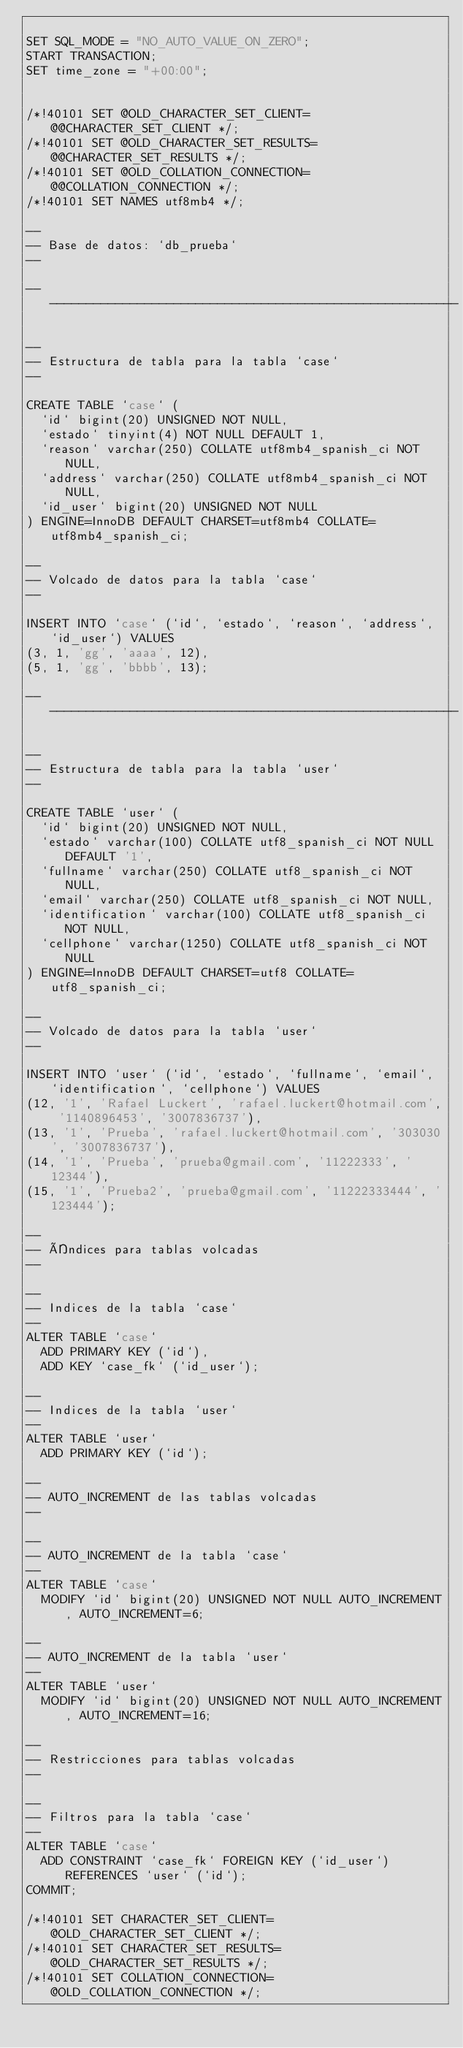Convert code to text. <code><loc_0><loc_0><loc_500><loc_500><_SQL_>
SET SQL_MODE = "NO_AUTO_VALUE_ON_ZERO";
START TRANSACTION;
SET time_zone = "+00:00";


/*!40101 SET @OLD_CHARACTER_SET_CLIENT=@@CHARACTER_SET_CLIENT */;
/*!40101 SET @OLD_CHARACTER_SET_RESULTS=@@CHARACTER_SET_RESULTS */;
/*!40101 SET @OLD_COLLATION_CONNECTION=@@COLLATION_CONNECTION */;
/*!40101 SET NAMES utf8mb4 */;

--
-- Base de datos: `db_prueba`
--

-- --------------------------------------------------------

--
-- Estructura de tabla para la tabla `case`
--

CREATE TABLE `case` (
  `id` bigint(20) UNSIGNED NOT NULL,
  `estado` tinyint(4) NOT NULL DEFAULT 1,
  `reason` varchar(250) COLLATE utf8mb4_spanish_ci NOT NULL,
  `address` varchar(250) COLLATE utf8mb4_spanish_ci NOT NULL,
  `id_user` bigint(20) UNSIGNED NOT NULL
) ENGINE=InnoDB DEFAULT CHARSET=utf8mb4 COLLATE=utf8mb4_spanish_ci;

--
-- Volcado de datos para la tabla `case`
--

INSERT INTO `case` (`id`, `estado`, `reason`, `address`, `id_user`) VALUES
(3, 1, 'gg', 'aaaa', 12),
(5, 1, 'gg', 'bbbb', 13);

-- --------------------------------------------------------

--
-- Estructura de tabla para la tabla `user`
--

CREATE TABLE `user` (
  `id` bigint(20) UNSIGNED NOT NULL,
  `estado` varchar(100) COLLATE utf8_spanish_ci NOT NULL DEFAULT '1',
  `fullname` varchar(250) COLLATE utf8_spanish_ci NOT NULL,
  `email` varchar(250) COLLATE utf8_spanish_ci NOT NULL,
  `identification` varchar(100) COLLATE utf8_spanish_ci NOT NULL,
  `cellphone` varchar(1250) COLLATE utf8_spanish_ci NOT NULL
) ENGINE=InnoDB DEFAULT CHARSET=utf8 COLLATE=utf8_spanish_ci;

--
-- Volcado de datos para la tabla `user`
--

INSERT INTO `user` (`id`, `estado`, `fullname`, `email`, `identification`, `cellphone`) VALUES
(12, '1', 'Rafael Luckert', 'rafael.luckert@hotmail.com', '1140896453', '3007836737'),
(13, '1', 'Prueba', 'rafael.luckert@hotmail.com', '303030', '3007836737'),
(14, '1', 'Prueba', 'prueba@gmail.com', '11222333', '12344'),
(15, '1', 'Prueba2', 'prueba@gmail.com', '11222333444', '123444');

--
-- Índices para tablas volcadas
--

--
-- Indices de la tabla `case`
--
ALTER TABLE `case`
  ADD PRIMARY KEY (`id`),
  ADD KEY `case_fk` (`id_user`);

--
-- Indices de la tabla `user`
--
ALTER TABLE `user`
  ADD PRIMARY KEY (`id`);

--
-- AUTO_INCREMENT de las tablas volcadas
--

--
-- AUTO_INCREMENT de la tabla `case`
--
ALTER TABLE `case`
  MODIFY `id` bigint(20) UNSIGNED NOT NULL AUTO_INCREMENT, AUTO_INCREMENT=6;

--
-- AUTO_INCREMENT de la tabla `user`
--
ALTER TABLE `user`
  MODIFY `id` bigint(20) UNSIGNED NOT NULL AUTO_INCREMENT, AUTO_INCREMENT=16;

--
-- Restricciones para tablas volcadas
--

--
-- Filtros para la tabla `case`
--
ALTER TABLE `case`
  ADD CONSTRAINT `case_fk` FOREIGN KEY (`id_user`) REFERENCES `user` (`id`);
COMMIT;

/*!40101 SET CHARACTER_SET_CLIENT=@OLD_CHARACTER_SET_CLIENT */;
/*!40101 SET CHARACTER_SET_RESULTS=@OLD_CHARACTER_SET_RESULTS */;
/*!40101 SET COLLATION_CONNECTION=@OLD_COLLATION_CONNECTION */;
</code> 